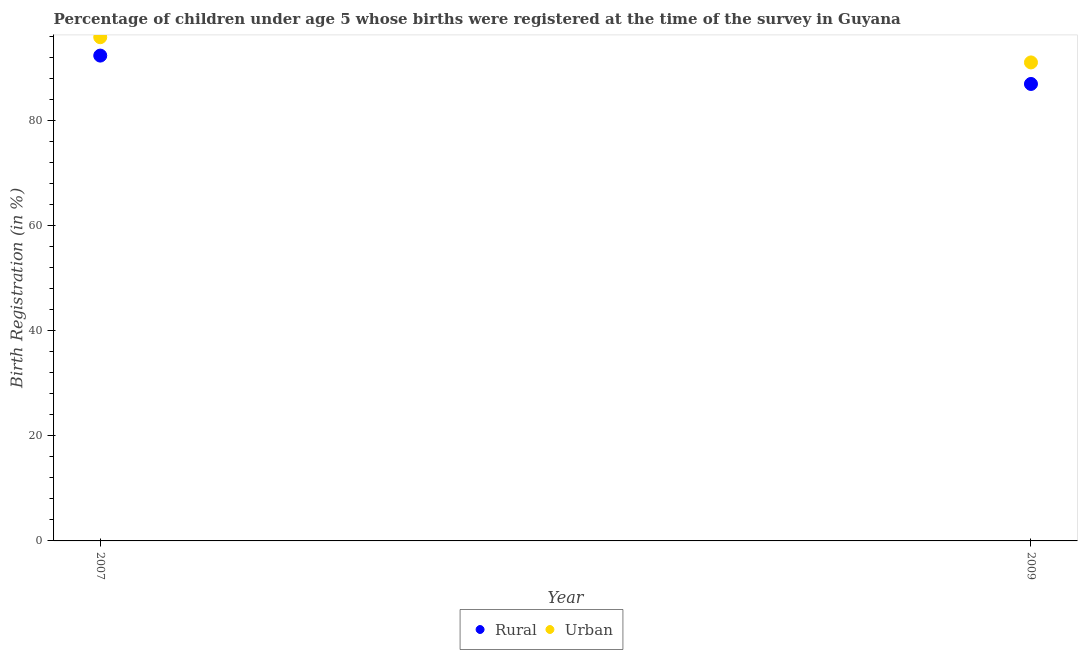What is the urban birth registration in 2007?
Ensure brevity in your answer.  95.9. Across all years, what is the maximum rural birth registration?
Provide a succinct answer. 92.4. Across all years, what is the minimum urban birth registration?
Make the answer very short. 91.1. In which year was the urban birth registration maximum?
Your response must be concise. 2007. What is the total urban birth registration in the graph?
Ensure brevity in your answer.  187. What is the difference between the rural birth registration in 2007 and that in 2009?
Give a very brief answer. 5.4. What is the difference between the rural birth registration in 2007 and the urban birth registration in 2009?
Give a very brief answer. 1.3. What is the average rural birth registration per year?
Your answer should be very brief. 89.7. In how many years, is the rural birth registration greater than 16 %?
Your answer should be compact. 2. What is the ratio of the rural birth registration in 2007 to that in 2009?
Give a very brief answer. 1.06. Is the urban birth registration in 2007 less than that in 2009?
Offer a very short reply. No. In how many years, is the urban birth registration greater than the average urban birth registration taken over all years?
Keep it short and to the point. 1. Does the urban birth registration monotonically increase over the years?
Your answer should be very brief. No. Is the urban birth registration strictly greater than the rural birth registration over the years?
Provide a succinct answer. Yes. How many years are there in the graph?
Provide a succinct answer. 2. What is the difference between two consecutive major ticks on the Y-axis?
Offer a very short reply. 20. Are the values on the major ticks of Y-axis written in scientific E-notation?
Offer a very short reply. No. Where does the legend appear in the graph?
Keep it short and to the point. Bottom center. What is the title of the graph?
Your answer should be very brief. Percentage of children under age 5 whose births were registered at the time of the survey in Guyana. Does "Forest land" appear as one of the legend labels in the graph?
Your response must be concise. No. What is the label or title of the X-axis?
Offer a very short reply. Year. What is the label or title of the Y-axis?
Give a very brief answer. Birth Registration (in %). What is the Birth Registration (in %) in Rural in 2007?
Ensure brevity in your answer.  92.4. What is the Birth Registration (in %) of Urban in 2007?
Provide a short and direct response. 95.9. What is the Birth Registration (in %) in Urban in 2009?
Provide a short and direct response. 91.1. Across all years, what is the maximum Birth Registration (in %) of Rural?
Give a very brief answer. 92.4. Across all years, what is the maximum Birth Registration (in %) of Urban?
Make the answer very short. 95.9. Across all years, what is the minimum Birth Registration (in %) of Urban?
Provide a short and direct response. 91.1. What is the total Birth Registration (in %) in Rural in the graph?
Ensure brevity in your answer.  179.4. What is the total Birth Registration (in %) of Urban in the graph?
Offer a very short reply. 187. What is the difference between the Birth Registration (in %) in Rural in 2007 and the Birth Registration (in %) in Urban in 2009?
Keep it short and to the point. 1.3. What is the average Birth Registration (in %) in Rural per year?
Your answer should be very brief. 89.7. What is the average Birth Registration (in %) of Urban per year?
Your answer should be very brief. 93.5. In the year 2007, what is the difference between the Birth Registration (in %) of Rural and Birth Registration (in %) of Urban?
Provide a short and direct response. -3.5. What is the ratio of the Birth Registration (in %) in Rural in 2007 to that in 2009?
Make the answer very short. 1.06. What is the ratio of the Birth Registration (in %) in Urban in 2007 to that in 2009?
Offer a very short reply. 1.05. What is the difference between the highest and the second highest Birth Registration (in %) of Rural?
Provide a short and direct response. 5.4. 